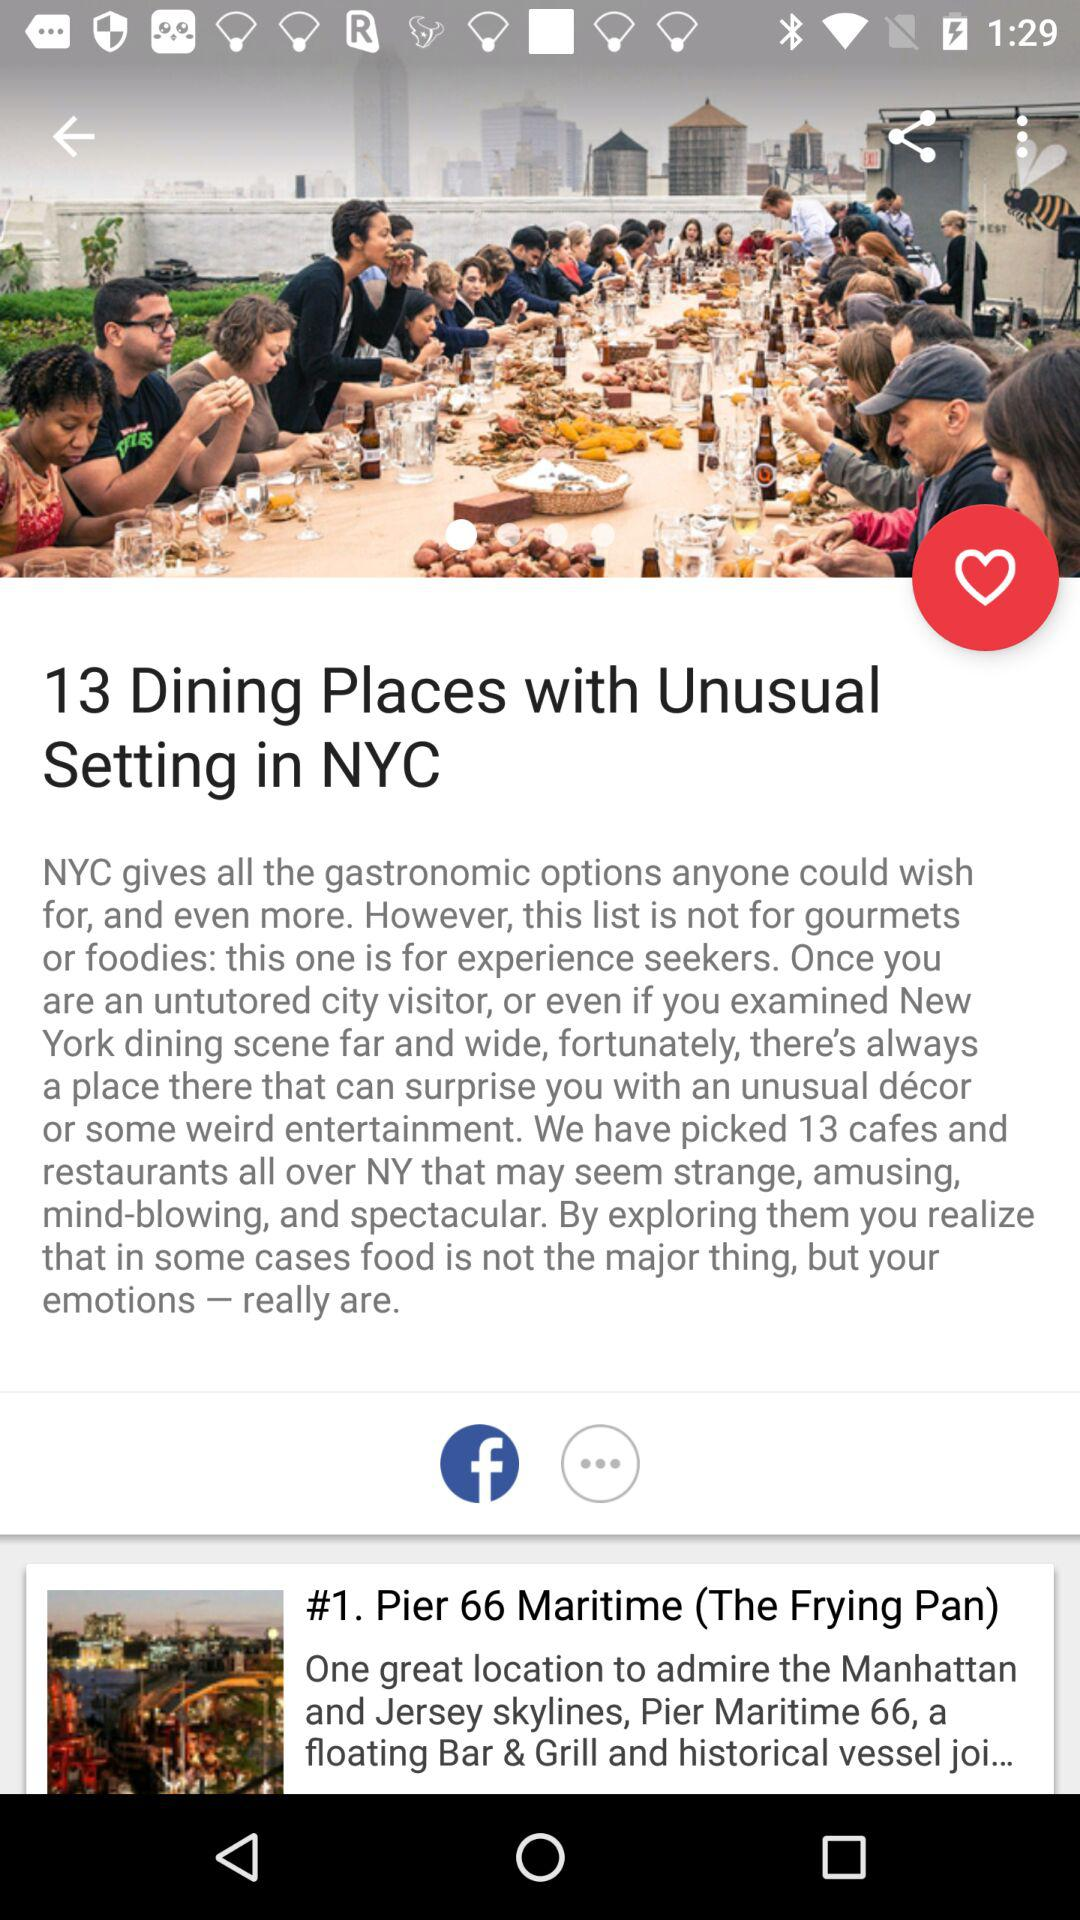How many cafes and restaurants are picked all over NY? The number of cafes and restaurants is 13. 